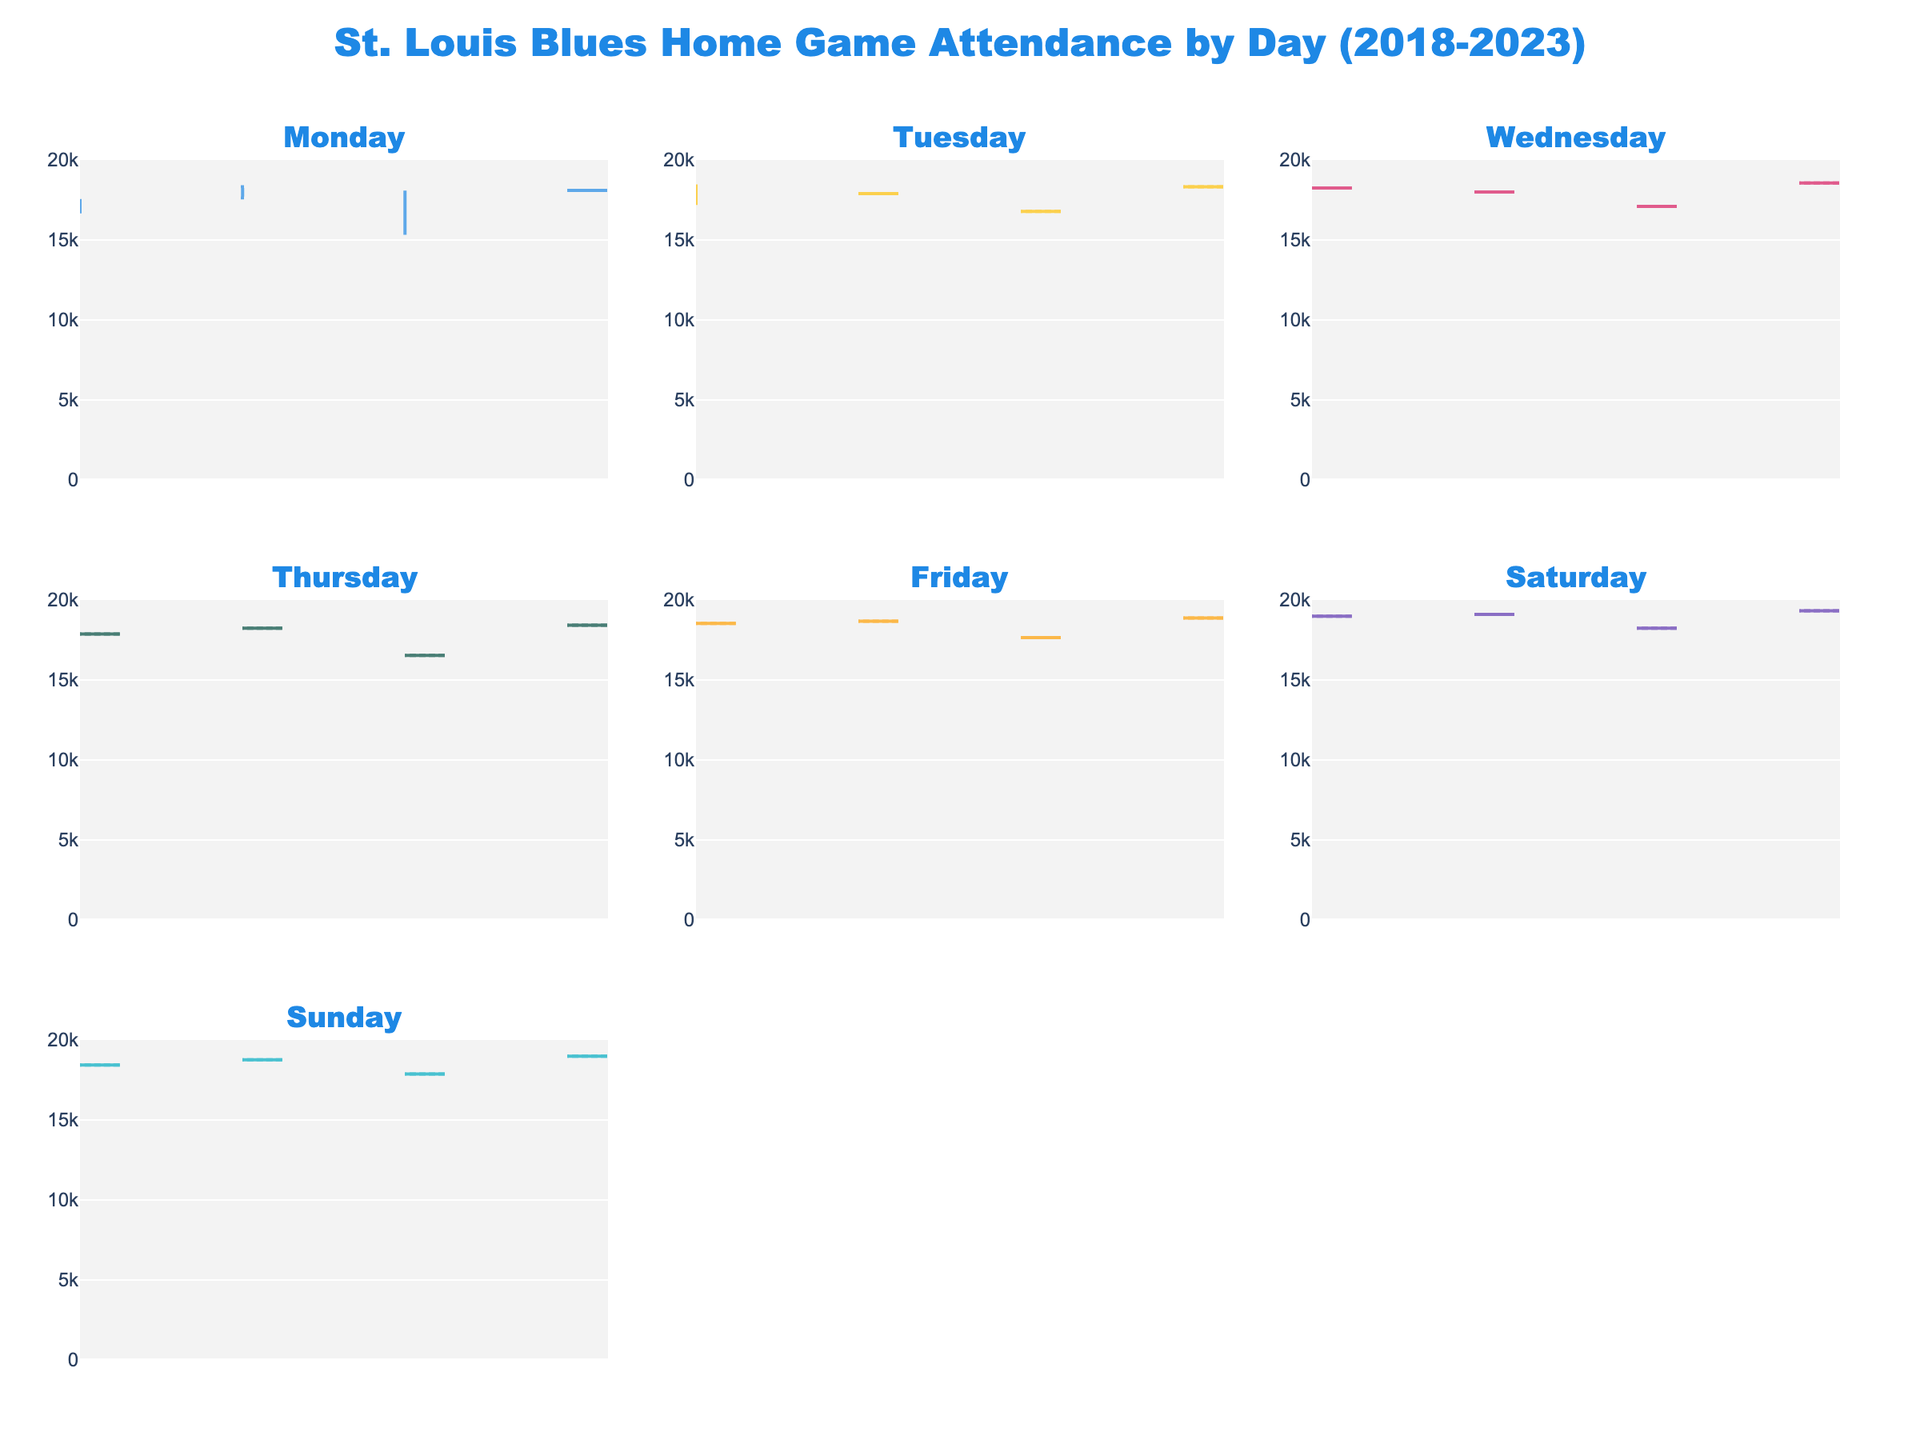What is the title of the figure? The title is usually located at the top of the figure, and here it states "St. Louis Blues Home Game Attendance by Day (2018-2023)."
Answer: St. Louis Blues Home Game Attendance by Day (2018-2023) Which day's attendance data is displayed in the first subplot? The first subplot is on the top left, corresponding to Monday as indicated by the subplot titles.
Answer: Monday How does the attendance on Fridays compare to other days? We need to visually inspect the violin plots for Fridays and compare the range and median with other days. The Friday plot consistently shows higher attendance with medians close to or above 18,000, higher than most other days.
Answer: Higher Is there any day that shows zero attendance? By inspecting the violin plots, we can see gaps for the 2020-2021 season across all days, indicating zero attendance due to disruptions.
Answer: Yes, all days in 2020-2021 What is the pattern in attendance on Saturdays? Saturdays have a violin plot with consistently high attendance. The plots are wider and positioned above 18,000 for most seasons, showing no zero attendance, indicating high popularity or capacity.
Answer: Consistently high Did the attendance on Wednesdays increase or decrease from the 2018-2019 season to the 2022-2023 season? Compare the violin plot's median lines and overall spread for Wednesdays for both seasons. The median for 2022-2023 is higher than 2018-2019, indicating an increase.
Answer: Increase What was the approximate range of attendance on Sundays in the 2022-2023 season? Inspect the 2022-2023 violin plot for Sundays; it ranges approximately from 18,900 to just below 19,900.
Answer: 18,900 to 19,900 Which day shows the most variation in attendance figures? We compare the widths of the violin plots across days. The widest plots with the most spread will indicate higher variation. Sunday seems to be the most variable, extending over a broader range of values.
Answer: Sunday How does the attendance on Mondays in the 2018-2019 season compare to the 2022-2023 season? Inspect the violin plots for Mondays in both seasons. The attendance in 2022-2023 is slightly higher and broader, indicating a slight increase and more variation.
Answer: Slightly higher in 2022-2023 How do the median attendance figures for Saturdays and Wednesdays in the 2019-2020 season compare? Check the median lines within the violin plots for both days in the 2019-2020 subplot. Both have median lines around 19000, but Saturday appears marginally higher.
Answer: Saturday is higher 